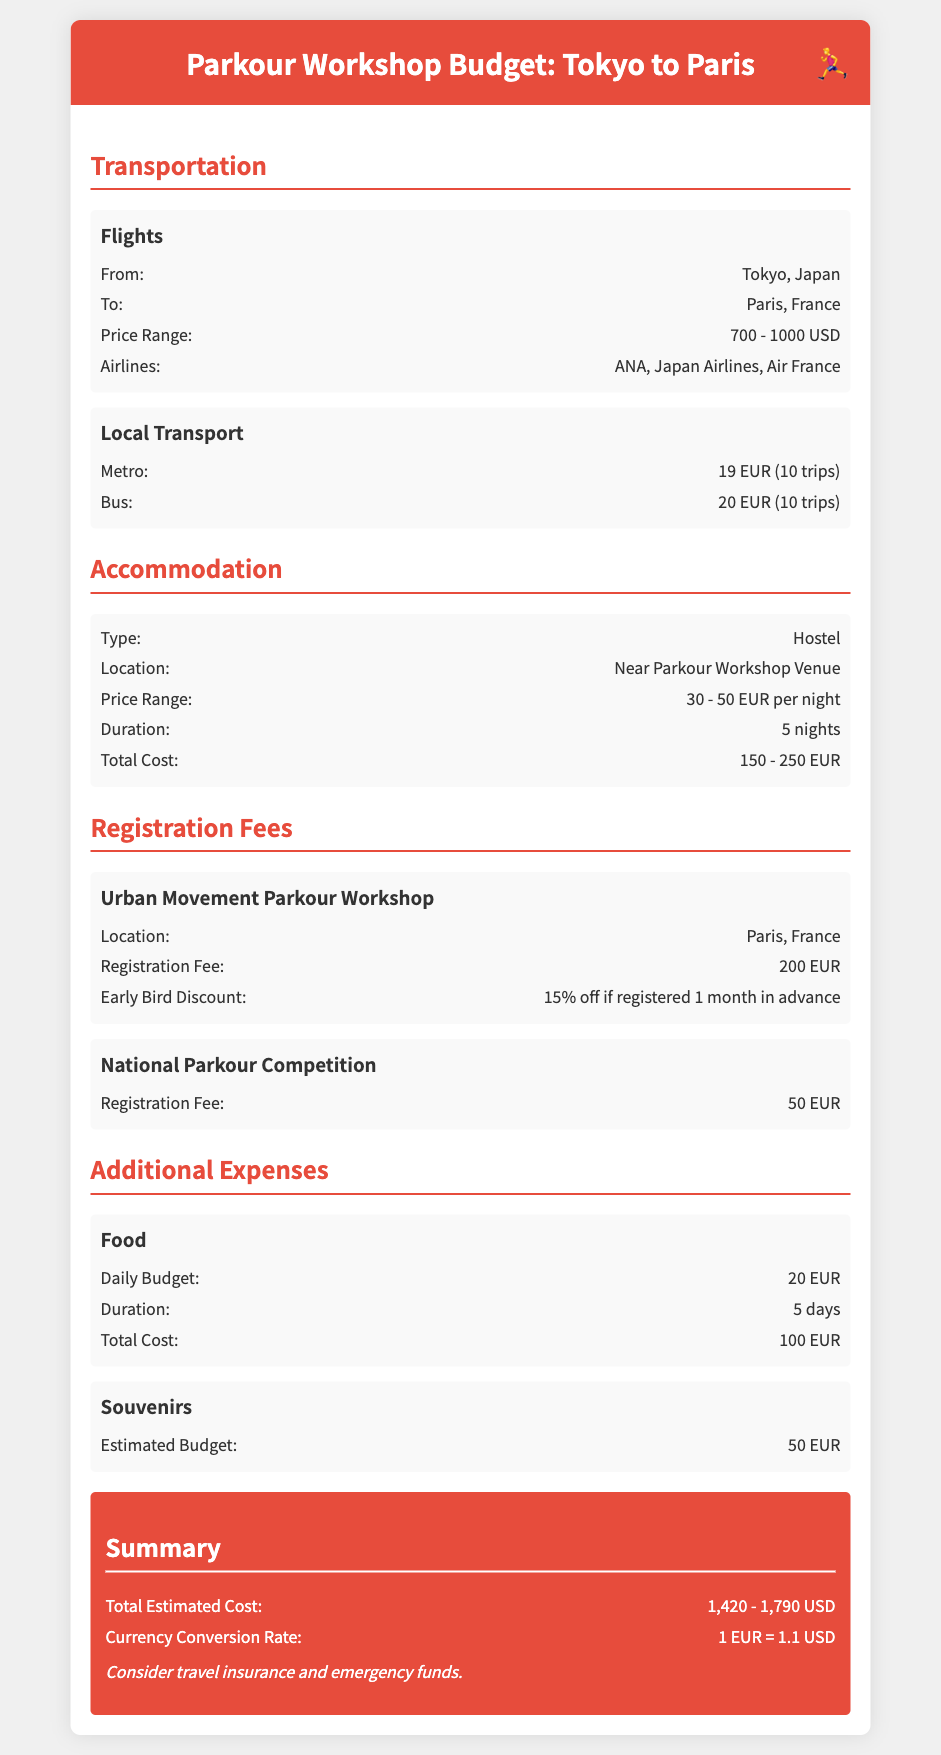What is the price range for flights? The document states that the price range for flights is 700 - 1000 USD.
Answer: 700 - 1000 USD What is the total cost for accommodation? The total cost for accommodation is calculated based on a stay of 5 nights at a price range of 30 - 50 EUR per night, resulting in 150 - 250 EUR.
Answer: 150 - 250 EUR What is the registration fee for the Urban Movement Parkour Workshop? The document specifies that the registration fee for the Urban Movement Parkour Workshop is 200 EUR.
Answer: 200 EUR How much is the daily budget for food? The daily budget for food is stated as 20 EUR in the document.
Answer: 20 EUR What is the estimated budget for souvenirs? The document mentions an estimated budget of 50 EUR for souvenirs.
Answer: 50 EUR What is the total estimated cost for the trip? The document summarizes the total estimated cost as 1,420 - 1,790 USD.
Answer: 1,420 - 1,790 USD What is the duration of the accommodation stay? The accommodation stay duration is noted to be 5 nights.
Answer: 5 nights What is the early bird discount for the registration fee? The document mentions a 15% discount if registered 1 month in advance.
Answer: 15% off 